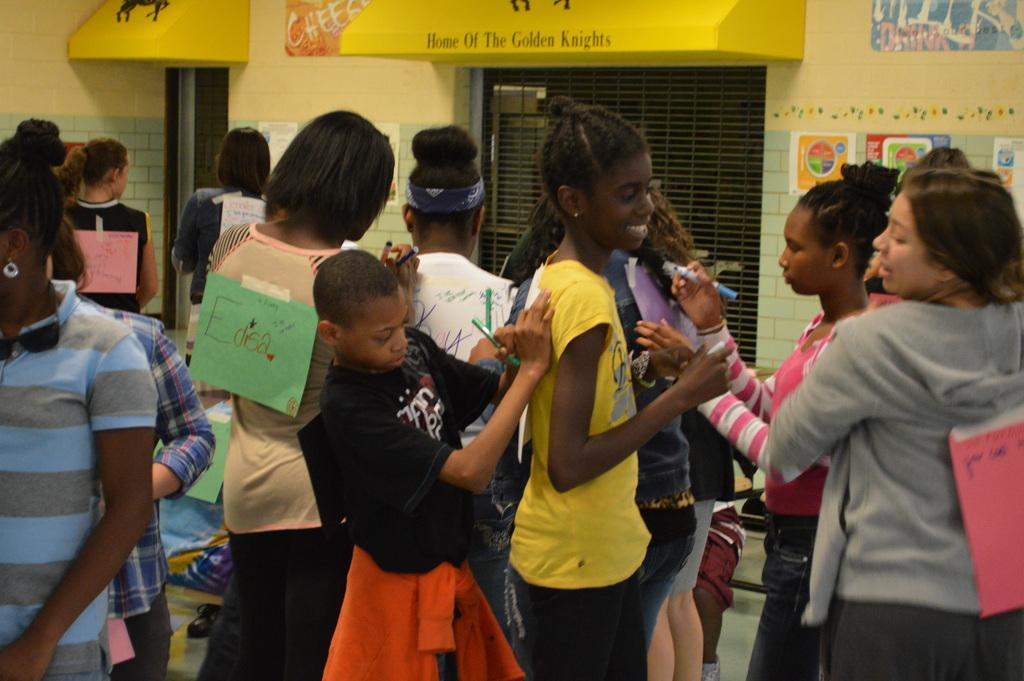What are the people in the image doing? The people in the image are standing and holding pens. What can be seen on the walls in the background? There are pipes attached to the walls in the background. What other objects are visible in the background? There are grills and advertisements in the background. How many cows are visible in the image? There are no cows present in the image. What type of ink is being used by the people holding pens in the image? The type of ink being used cannot be determined from the image, as it does not show the ink itself. 